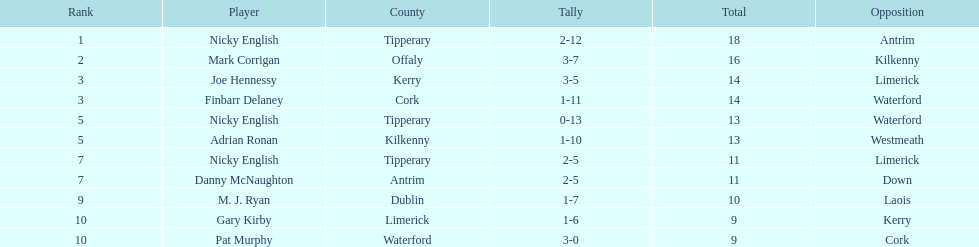Give me the full table as a dictionary. {'header': ['Rank', 'Player', 'County', 'Tally', 'Total', 'Opposition'], 'rows': [['1', 'Nicky English', 'Tipperary', '2-12', '18', 'Antrim'], ['2', 'Mark Corrigan', 'Offaly', '3-7', '16', 'Kilkenny'], ['3', 'Joe Hennessy', 'Kerry', '3-5', '14', 'Limerick'], ['3', 'Finbarr Delaney', 'Cork', '1-11', '14', 'Waterford'], ['5', 'Nicky English', 'Tipperary', '0-13', '13', 'Waterford'], ['5', 'Adrian Ronan', 'Kilkenny', '1-10', '13', 'Westmeath'], ['7', 'Nicky English', 'Tipperary', '2-5', '11', 'Limerick'], ['7', 'Danny McNaughton', 'Antrim', '2-5', '11', 'Down'], ['9', 'M. J. Ryan', 'Dublin', '1-7', '10', 'Laois'], ['10', 'Gary Kirby', 'Limerick', '1-6', '9', 'Kerry'], ['10', 'Pat Murphy', 'Waterford', '3-0', '9', 'Cork']]} What is the total sum when you add up all the numbers? 138. 